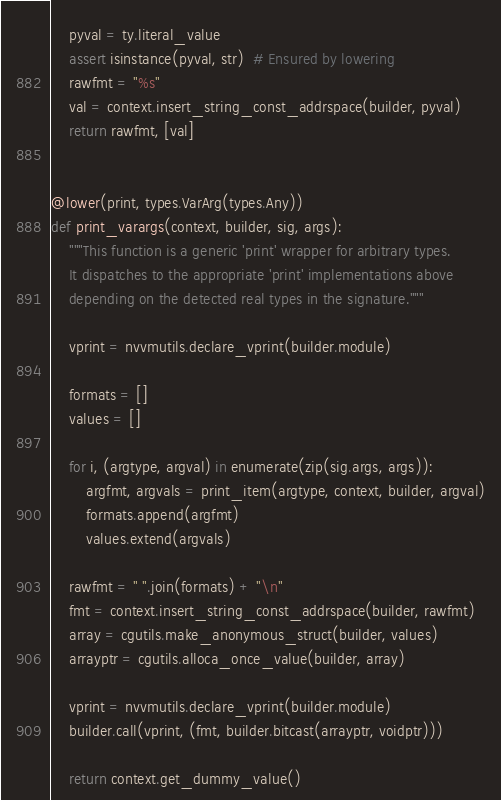<code> <loc_0><loc_0><loc_500><loc_500><_Python_>    pyval = ty.literal_value
    assert isinstance(pyval, str)  # Ensured by lowering
    rawfmt = "%s"
    val = context.insert_string_const_addrspace(builder, pyval)
    return rawfmt, [val]


@lower(print, types.VarArg(types.Any))
def print_varargs(context, builder, sig, args):
    """This function is a generic 'print' wrapper for arbitrary types.
    It dispatches to the appropriate 'print' implementations above
    depending on the detected real types in the signature."""

    vprint = nvvmutils.declare_vprint(builder.module)

    formats = []
    values = []

    for i, (argtype, argval) in enumerate(zip(sig.args, args)):
        argfmt, argvals = print_item(argtype, context, builder, argval)
        formats.append(argfmt)
        values.extend(argvals)

    rawfmt = " ".join(formats) + "\n"
    fmt = context.insert_string_const_addrspace(builder, rawfmt)
    array = cgutils.make_anonymous_struct(builder, values)
    arrayptr = cgutils.alloca_once_value(builder, array)

    vprint = nvvmutils.declare_vprint(builder.module)
    builder.call(vprint, (fmt, builder.bitcast(arrayptr, voidptr)))

    return context.get_dummy_value()
</code> 